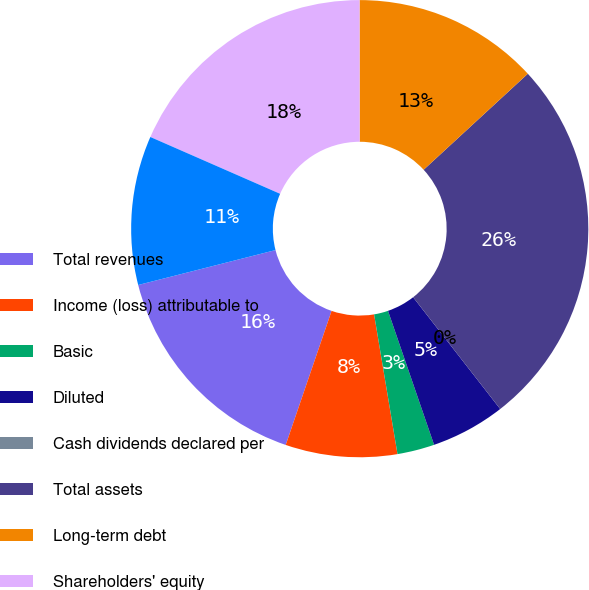Convert chart. <chart><loc_0><loc_0><loc_500><loc_500><pie_chart><fcel>Total revenues<fcel>Income (loss) attributable to<fcel>Basic<fcel>Diluted<fcel>Cash dividends declared per<fcel>Total assets<fcel>Long-term debt<fcel>Shareholders' equity<fcel>Common shares outstanding<nl><fcel>15.79%<fcel>7.89%<fcel>2.63%<fcel>5.26%<fcel>0.0%<fcel>26.32%<fcel>13.16%<fcel>18.42%<fcel>10.53%<nl></chart> 